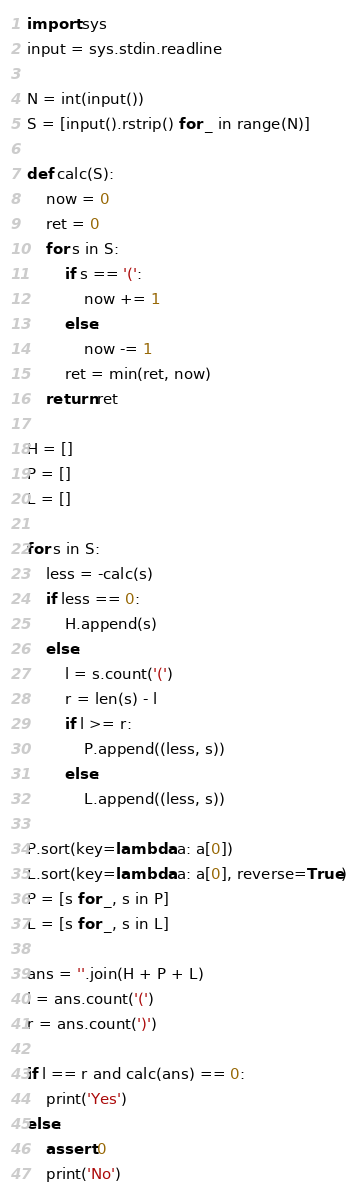<code> <loc_0><loc_0><loc_500><loc_500><_Python_>import sys
input = sys.stdin.readline

N = int(input())
S = [input().rstrip() for _ in range(N)]

def calc(S):
    now = 0
    ret = 0
    for s in S:
        if s == '(':
            now += 1
        else:
            now -= 1
        ret = min(ret, now)
    return ret

H = []
P = []
L = []

for s in S:
    less = -calc(s)
    if less == 0:
        H.append(s)
    else:
        l = s.count('(')
        r = len(s) - l
        if l >= r:
            P.append((less, s))
        else:
            L.append((less, s))

P.sort(key=lambda a: a[0])
L.sort(key=lambda a: a[0], reverse=True)
P = [s for _, s in P]
L = [s for _, s in L]

ans = ''.join(H + P + L)
l = ans.count('(')
r = ans.count(')')

if l == r and calc(ans) == 0:
    print('Yes')
else:
    assert 0
    print('No')
</code> 